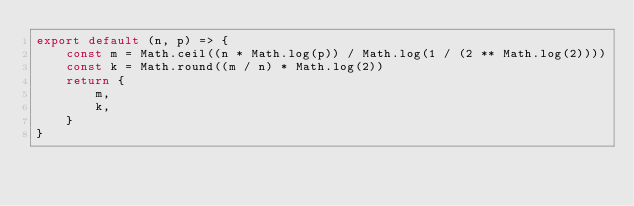<code> <loc_0><loc_0><loc_500><loc_500><_JavaScript_>export default (n, p) => {
    const m = Math.ceil((n * Math.log(p)) / Math.log(1 / (2 ** Math.log(2))))
    const k = Math.round((m / n) * Math.log(2))
    return {
        m,
        k,
    }
}
</code> 